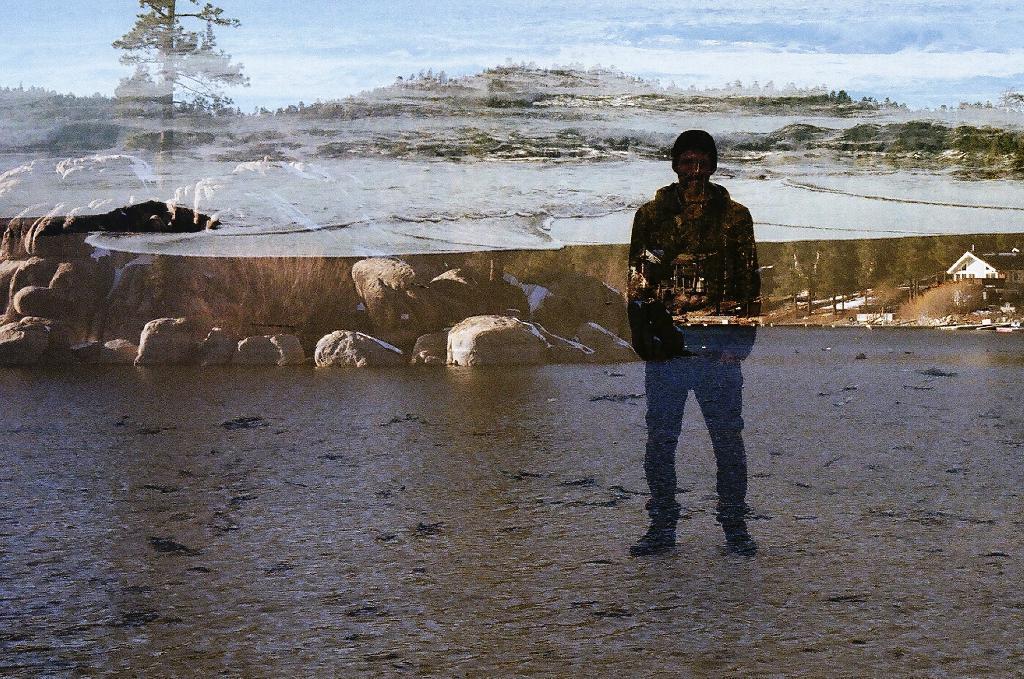In one or two sentences, can you explain what this image depicts? This image consists of a person, who is standing. There is a house on the right side. There are trees at the top. There is sky at the top. 